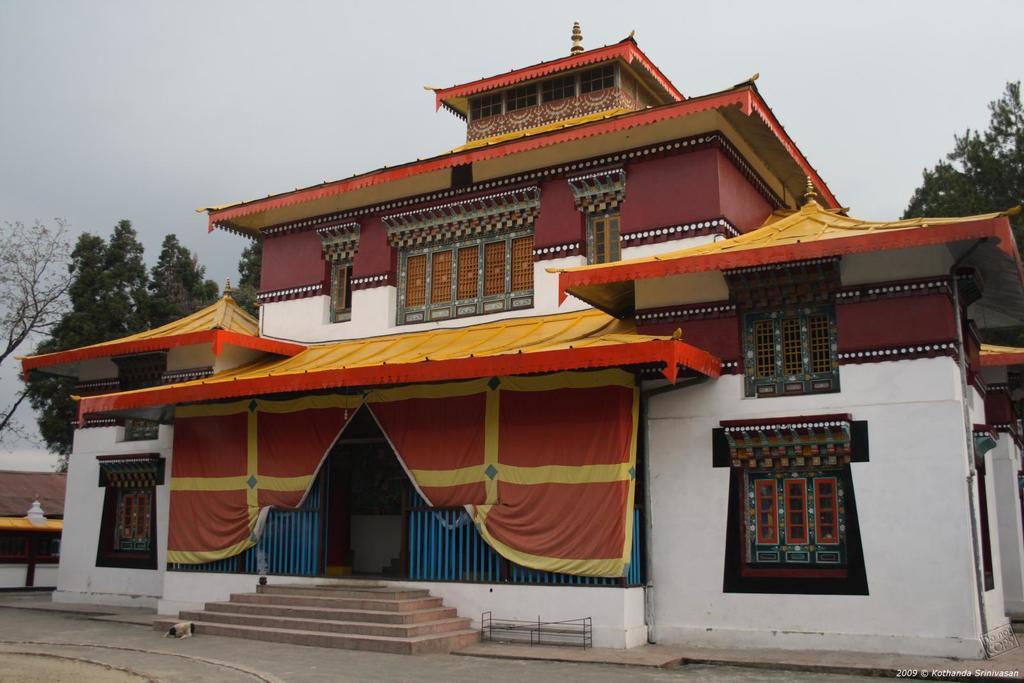Could you give a brief overview of what you see in this image? In the center of the image we can see a building. In the background there are trees and sky. At the bottom there is a road and stairs. 